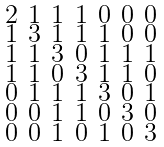<formula> <loc_0><loc_0><loc_500><loc_500>\begin{smallmatrix} 2 & 1 & 1 & 1 & 0 & 0 & 0 \\ 1 & 3 & 1 & 1 & 1 & 0 & 0 \\ 1 & 1 & 3 & 0 & 1 & 1 & 1 \\ 1 & 1 & 0 & 3 & 1 & 1 & 0 \\ 0 & 1 & 1 & 1 & 3 & 0 & 1 \\ 0 & 0 & 1 & 1 & 0 & 3 & 0 \\ 0 & 0 & 1 & 0 & 1 & 0 & 3 \end{smallmatrix}</formula> 